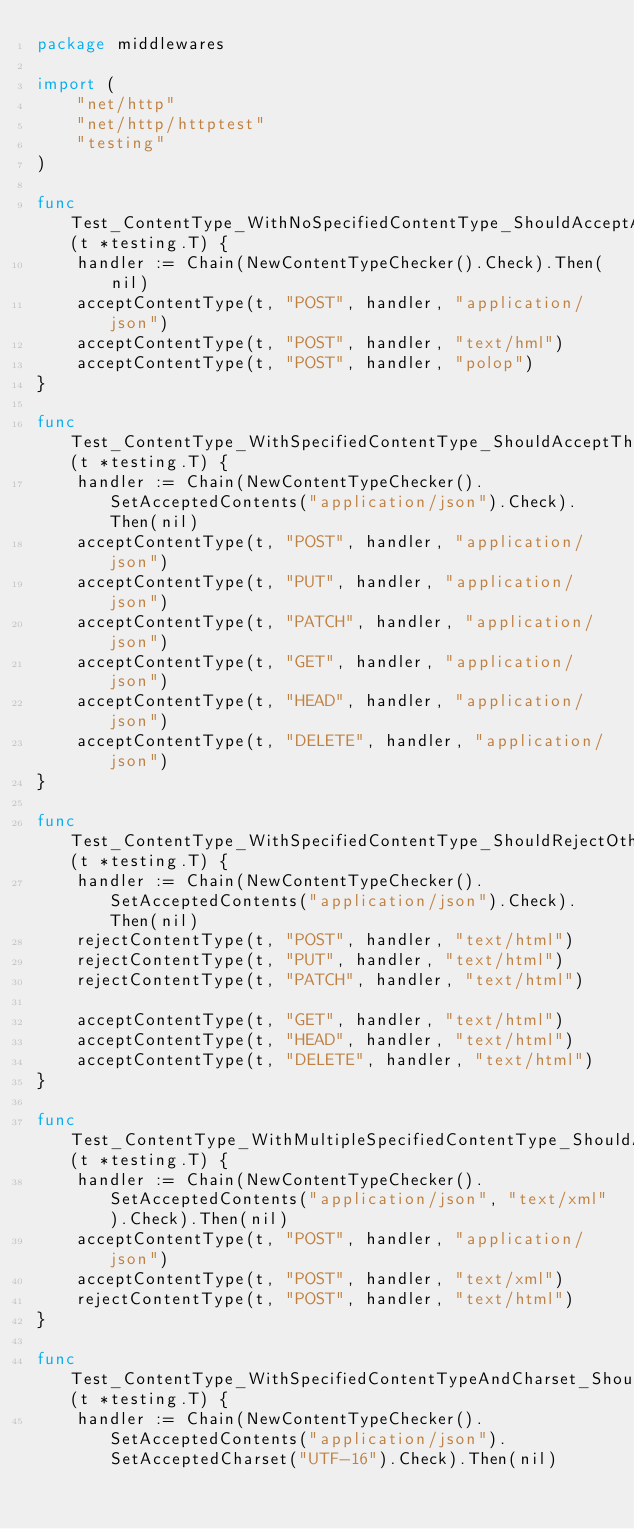Convert code to text. <code><loc_0><loc_0><loc_500><loc_500><_Go_>package middlewares

import (
	"net/http"
	"net/http/httptest"
	"testing"
)

func Test_ContentType_WithNoSpecifiedContentType_ShouldAcceptAnything(t *testing.T) {
	handler := Chain(NewContentTypeChecker().Check).Then(nil)
	acceptContentType(t, "POST", handler, "application/json")
	acceptContentType(t, "POST", handler, "text/hml")
	acceptContentType(t, "POST", handler, "polop")
}

func Test_ContentType_WithSpecifiedContentType_ShouldAcceptThisContentTypeForAllMethod(t *testing.T) {
	handler := Chain(NewContentTypeChecker().SetAcceptedContents("application/json").Check).Then(nil)
	acceptContentType(t, "POST", handler, "application/json")
	acceptContentType(t, "PUT", handler, "application/json")
	acceptContentType(t, "PATCH", handler, "application/json")
	acceptContentType(t, "GET", handler, "application/json")
	acceptContentType(t, "HEAD", handler, "application/json")
	acceptContentType(t, "DELETE", handler, "application/json")
}

func Test_ContentType_WithSpecifiedContentType_ShouldRejectOtherContentTypeOnlyForPostPutPatchMethods(t *testing.T) {
	handler := Chain(NewContentTypeChecker().SetAcceptedContents("application/json").Check).Then(nil)
	rejectContentType(t, "POST", handler, "text/html")
	rejectContentType(t, "PUT", handler, "text/html")
	rejectContentType(t, "PATCH", handler, "text/html")

	acceptContentType(t, "GET", handler, "text/html")
	acceptContentType(t, "HEAD", handler, "text/html")
	acceptContentType(t, "DELETE", handler, "text/html")
}

func Test_ContentType_WithMultipleSpecifiedContentType_ShouldAcceptAll(t *testing.T) {
	handler := Chain(NewContentTypeChecker().SetAcceptedContents("application/json", "text/xml").Check).Then(nil)
	acceptContentType(t, "POST", handler, "application/json")
	acceptContentType(t, "POST", handler, "text/xml")
	rejectContentType(t, "POST", handler, "text/html")
}

func Test_ContentType_WithSpecifiedContentTypeAndCharset_ShouldAcceptThisContentTypeWithTheCharset(t *testing.T) {
	handler := Chain(NewContentTypeChecker().SetAcceptedContents("application/json").SetAcceptedCharset("UTF-16").Check).Then(nil)</code> 